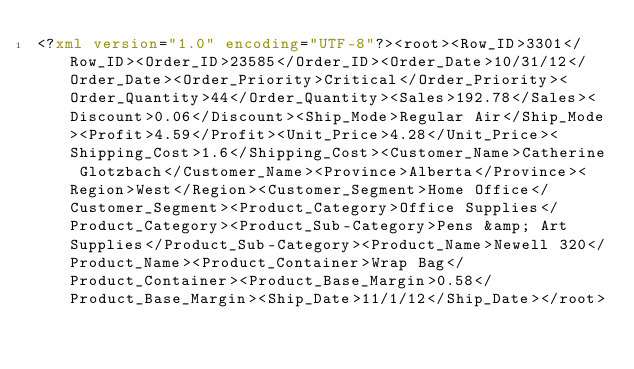Convert code to text. <code><loc_0><loc_0><loc_500><loc_500><_XML_><?xml version="1.0" encoding="UTF-8"?><root><Row_ID>3301</Row_ID><Order_ID>23585</Order_ID><Order_Date>10/31/12</Order_Date><Order_Priority>Critical</Order_Priority><Order_Quantity>44</Order_Quantity><Sales>192.78</Sales><Discount>0.06</Discount><Ship_Mode>Regular Air</Ship_Mode><Profit>4.59</Profit><Unit_Price>4.28</Unit_Price><Shipping_Cost>1.6</Shipping_Cost><Customer_Name>Catherine Glotzbach</Customer_Name><Province>Alberta</Province><Region>West</Region><Customer_Segment>Home Office</Customer_Segment><Product_Category>Office Supplies</Product_Category><Product_Sub-Category>Pens &amp; Art Supplies</Product_Sub-Category><Product_Name>Newell 320</Product_Name><Product_Container>Wrap Bag</Product_Container><Product_Base_Margin>0.58</Product_Base_Margin><Ship_Date>11/1/12</Ship_Date></root></code> 